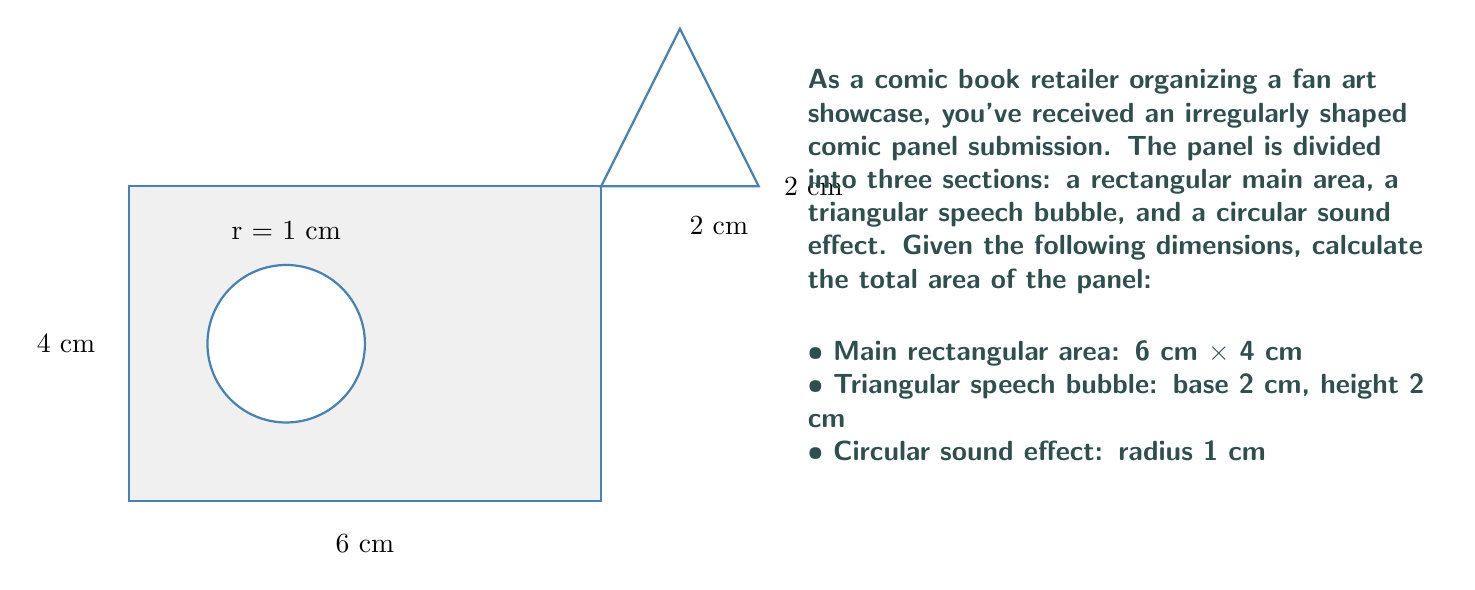Show me your answer to this math problem. To calculate the total area of the irregularly shaped comic panel, we need to sum the areas of its three components:

1. Rectangular main area:
   $$A_r = l \times w = 6 \text{ cm} \times 4 \text{ cm} = 24 \text{ cm}^2$$

2. Triangular speech bubble:
   $$A_t = \frac{1}{2} \times b \times h = \frac{1}{2} \times 2 \text{ cm} \times 2 \text{ cm} = 2 \text{ cm}^2$$

3. Circular sound effect:
   $$A_c = \pi r^2 = \pi \times (1 \text{ cm})^2 = \pi \text{ cm}^2$$

Now, we sum these areas:

$$A_{total} = A_r + A_t - A_c$$

We subtract the circular area because it's a cutout from the main rectangular area.

$$A_{total} = 24 \text{ cm}^2 + 2 \text{ cm}^2 - \pi \text{ cm}^2$$
$$A_{total} = 26 - \pi \text{ cm}^2$$

The exact value is $26 - \pi \text{ cm}^2$, but if we need a numerical approximation:

$$A_{total} \approx 26 - 3.14159 \approx 22.85841 \text{ cm}^2$$
Answer: $26 - \pi \text{ cm}^2$ (or approximately 22.86 cm²) 